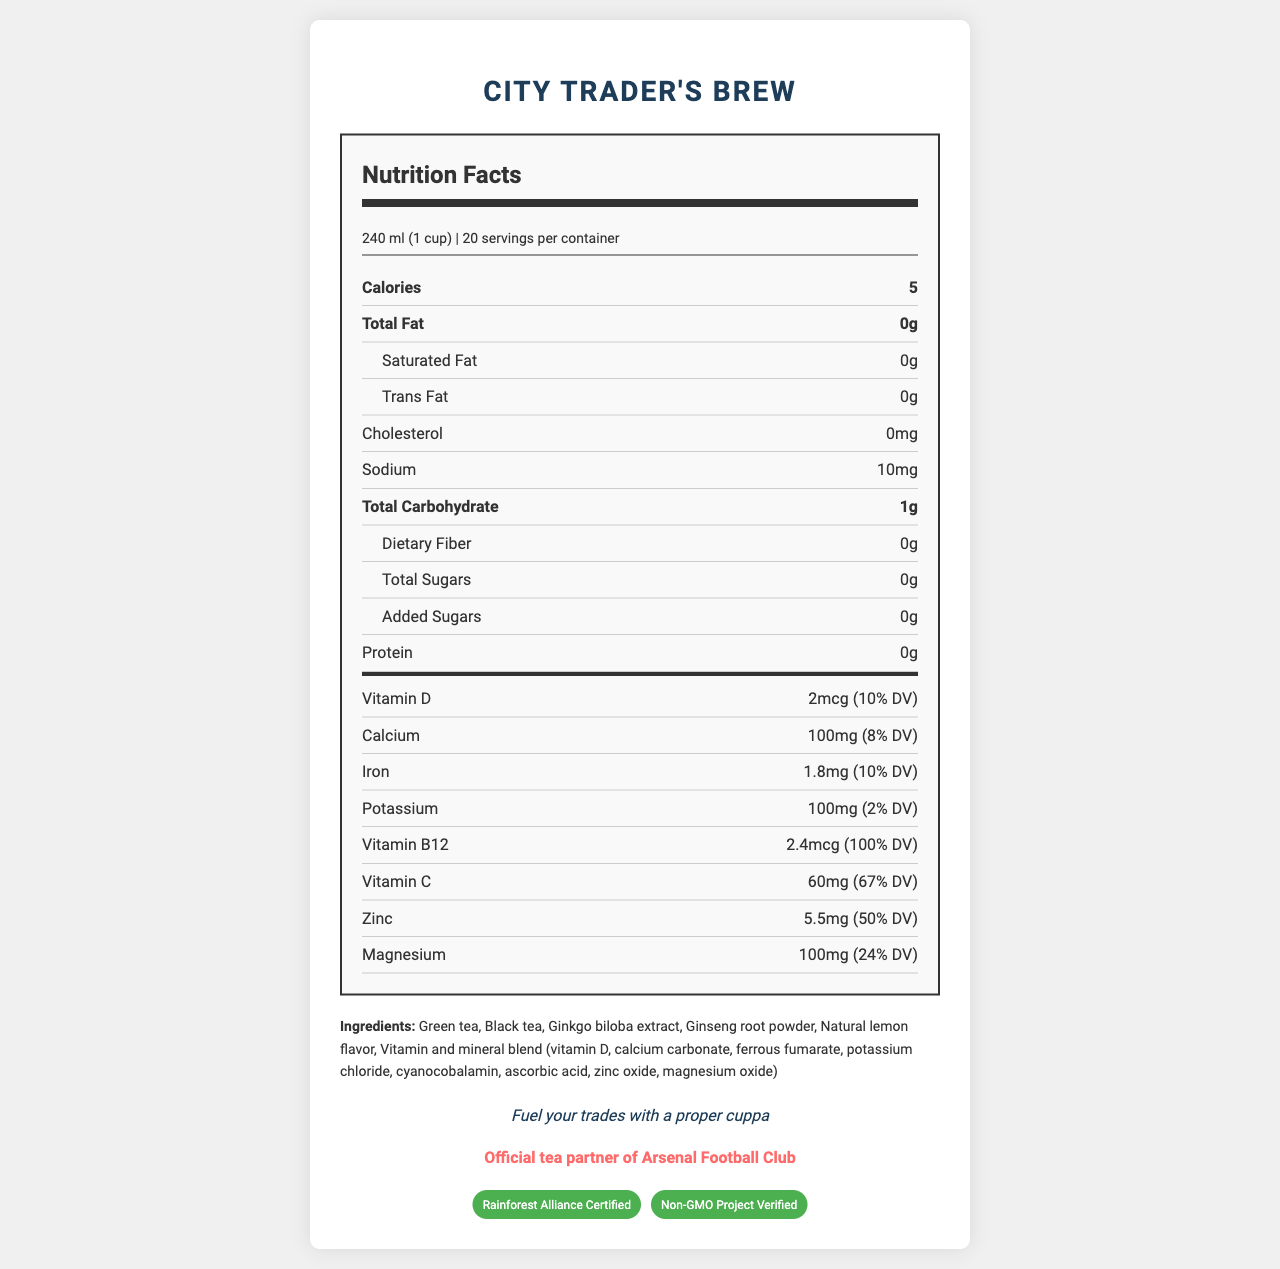what is the serving size? The serving size is listed at the beginning of the nutrition facts label.
Answer: 240 ml (1 cup) how many calories are in one serving? The calories per serving are listed prominently in the nutrition facts section.
Answer: 5 how many servings are in a container? The number of servings per container is clearly stated at the top of the nutrition facts.
Answer: 20 what vitamins are included in the tea blend? These vitamins are listed in the vitamins section of the nutrition facts.
Answer: Vitamin D, Vitamin B12, Vitamin C what is the protein content in one serving? The protein content per serving is listed near the bottom of the main nutrient section.
Answer: 0g Does the tea contain any fat? The total fat, saturated fat, and trans fat all are listed as 0g, indicating no fat content.
Answer: No how much magnesium is in one serving? A. 50mg B. 100mg C. 150mg According to the vitamins section, one serving contains 100mg of magnesium.
Answer: B which vitamin has the highest percentage of daily value (DV)? A. Vitamin D B. Vitamin B12 C. Vitamin C Vitamin B12 has 100% DV, the highest among the listed vitamins.
Answer: B is the product certified by any third-party organizations? Yes/No The certifications include Rainforest Alliance Certified and Non-GMO Project Verified, which are listed at the bottom of the document.
Answer: Yes what is the official tea partner of Arsenal Football Club? This information is highlighted in the soccer tie-in section near the bottom.
Answer: City Trader's Brew describe the main idea of the entire document. The document is essentially a nutrition facts label that includes details about serving size, nutrients, ingredients, as well as additional information about certifications, target market, and promotional affiliations.
Answer: The document provides detailed nutritional information for "City Trader's Brew," a vitamin-fortified tea blend targeted at financial professionals in London, highlighting its low-calorie content, essential vitamins and minerals, ingredients, preparation method, certifications, and endorsement by Arsenal Football Club. what is the sodium content in one serving? The sodium content per serving is listed in the nutrient section of the nutrition facts.
Answer: 10mg what is the allergen information for this product? This information is found in the ingredients and allergen section.
Answer: Produced in a facility that also processes soy and tree nuts how should this tea be prepared? The preparation steps are detailed in the document.
Answer: Steep 1 tea bag in hot water for 3-5 minutes what is the primary target market for this tea? This is specified in the target market section.
Answer: Financial professionals in the City of London what is the product's tagline? The tagline is presented in italics near the bottom of the document.
Answer: Fuel your trades with a proper cuppa what is the main source of energy in the tea blend? The document does not provide specific information about the main source of energy in the tea blend.
Answer: Cannot be determined 